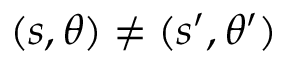<formula> <loc_0><loc_0><loc_500><loc_500>( s , \theta ) \neq ( s ^ { \prime } , \theta ^ { \prime } )</formula> 